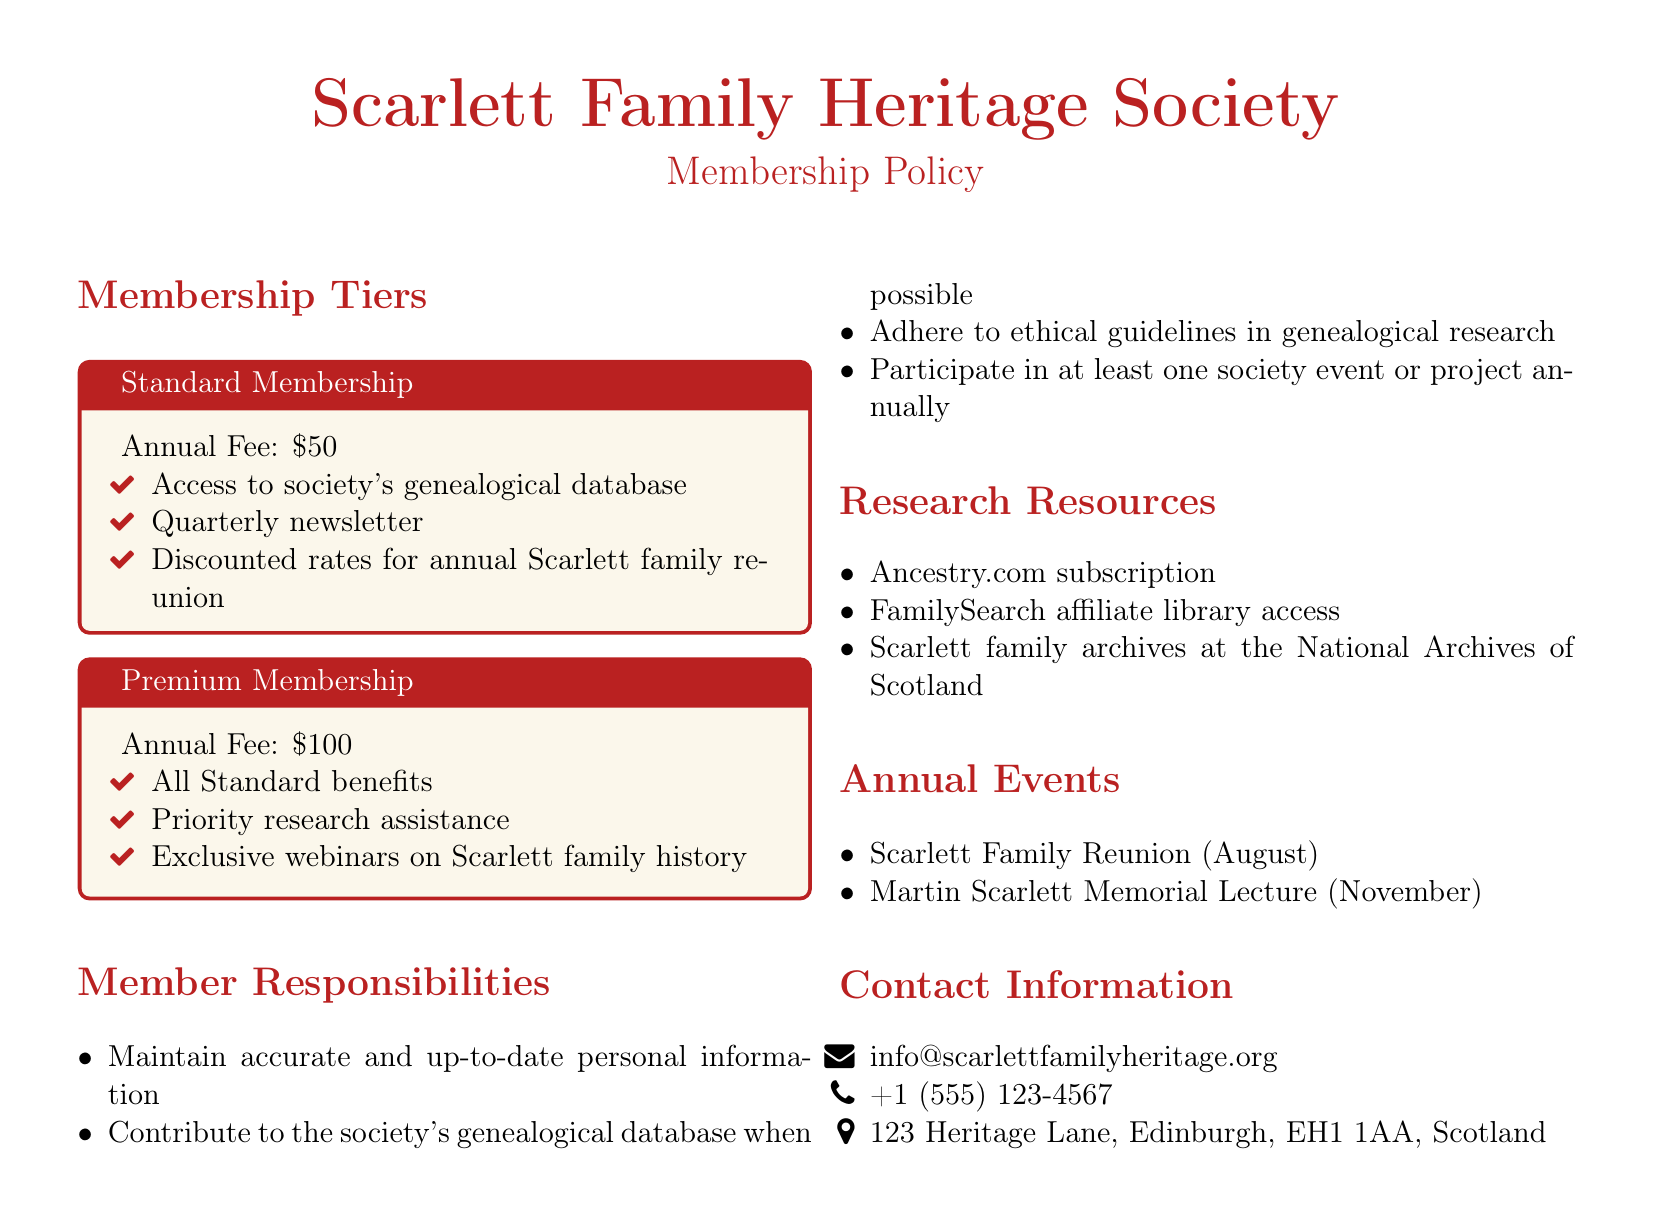What is the annual fee for Standard Membership? The annual fee for Standard Membership is listed in the document under the Standard Membership section.
Answer: $50 What is included in Premium Membership? The benefits of Premium Membership are detailed in the document under the Premium Membership section.
Answer: All Standard benefits, Priority research assistance, Exclusive webinars on Scarlett family history How many annual events are listed in the document? The document lists annual events under the Annual Events section, which provides a total count of these events.
Answer: 2 What is the email address for contacting the society? The email address is found in the Contact Information section of the document.
Answer: info@scarlettfamilyheritage.org What must members do at least once a year? This responsibility is mentioned in the Member Responsibilities section of the document.
Answer: Participate in at least one society event or project annually What type of resources are provided for research? The document mentions research resources, which are specified in the Research Resources section.
Answer: Ancestry.com subscription, FamilySearch affiliate library access, Scarlett family archives at the National Archives of Scotland What month is the Scarlett Family Reunion held? The month of the Scarlett Family Reunion is indicated in the Annual Events section of the document.
Answer: August How is the document structured? The structure of the document can be inferred from the sections it contains, which categorize different aspects of the membership policy.
Answer: Membership Tiers, Member Responsibilities, Research Resources, Annual Events, Contact Information 